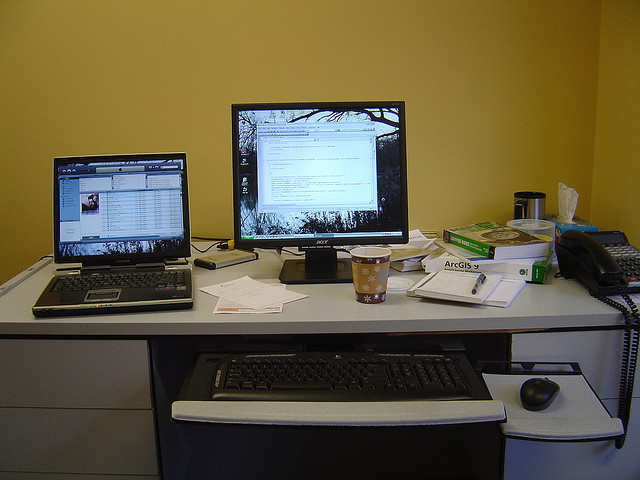Please extract the text content from this image. ArcGIS y 